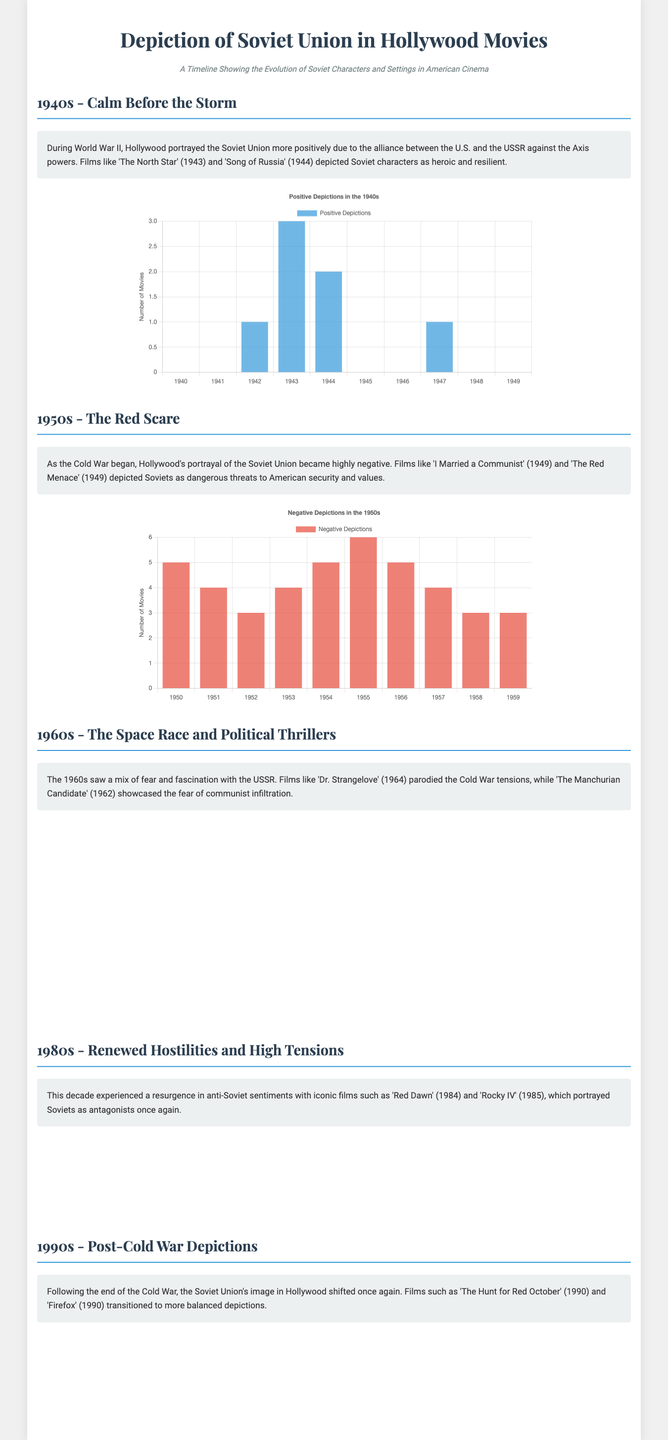What film in the 1940s depicted Soviet characters as heroic? The document mentions 'The North Star' (1943) as depicting Soviet characters positively during the 1940s.
Answer: The North Star In which year did the highest number of negative depictions occur in the 1950s? According to the bar chart, the year with the highest count of negative depictions in the 1950s is 1955, with a total of 6 movies.
Answer: 1955 How many films depicted Soviet characters in a parodic manner in the 1960s? The heatmap indicates that there is only 1 film with a parodic depiction in the year 1963 and 1964 in the 1960s.
Answer: 2 What is the trend of anti-Soviet movies in the 1980s? Referring to the bar chart, the trend shows an increase from 1980 to 1985, with a peak of 6 movies in 1985.
Answer: Increase What type of depiction dominated the 1990s according to the heatmap? The heatmap indicates that neutral depictions were prevalent in the 1990s, with the highest count of movies being neutral.
Answer: Neutral 